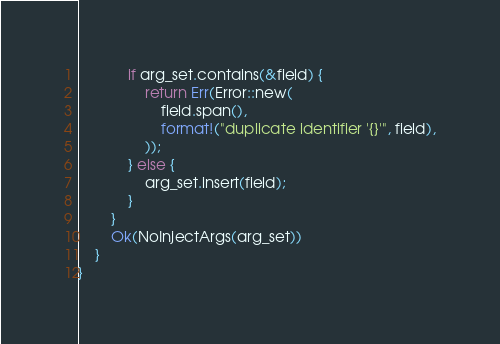<code> <loc_0><loc_0><loc_500><loc_500><_Rust_>            if arg_set.contains(&field) {
                return Err(Error::new(
                    field.span(),
                    format!("duplicate identifier '{}'", field),
                ));
            } else {
                arg_set.insert(field);
            }
        }
        Ok(NoInjectArgs(arg_set))
    }
}
</code> 